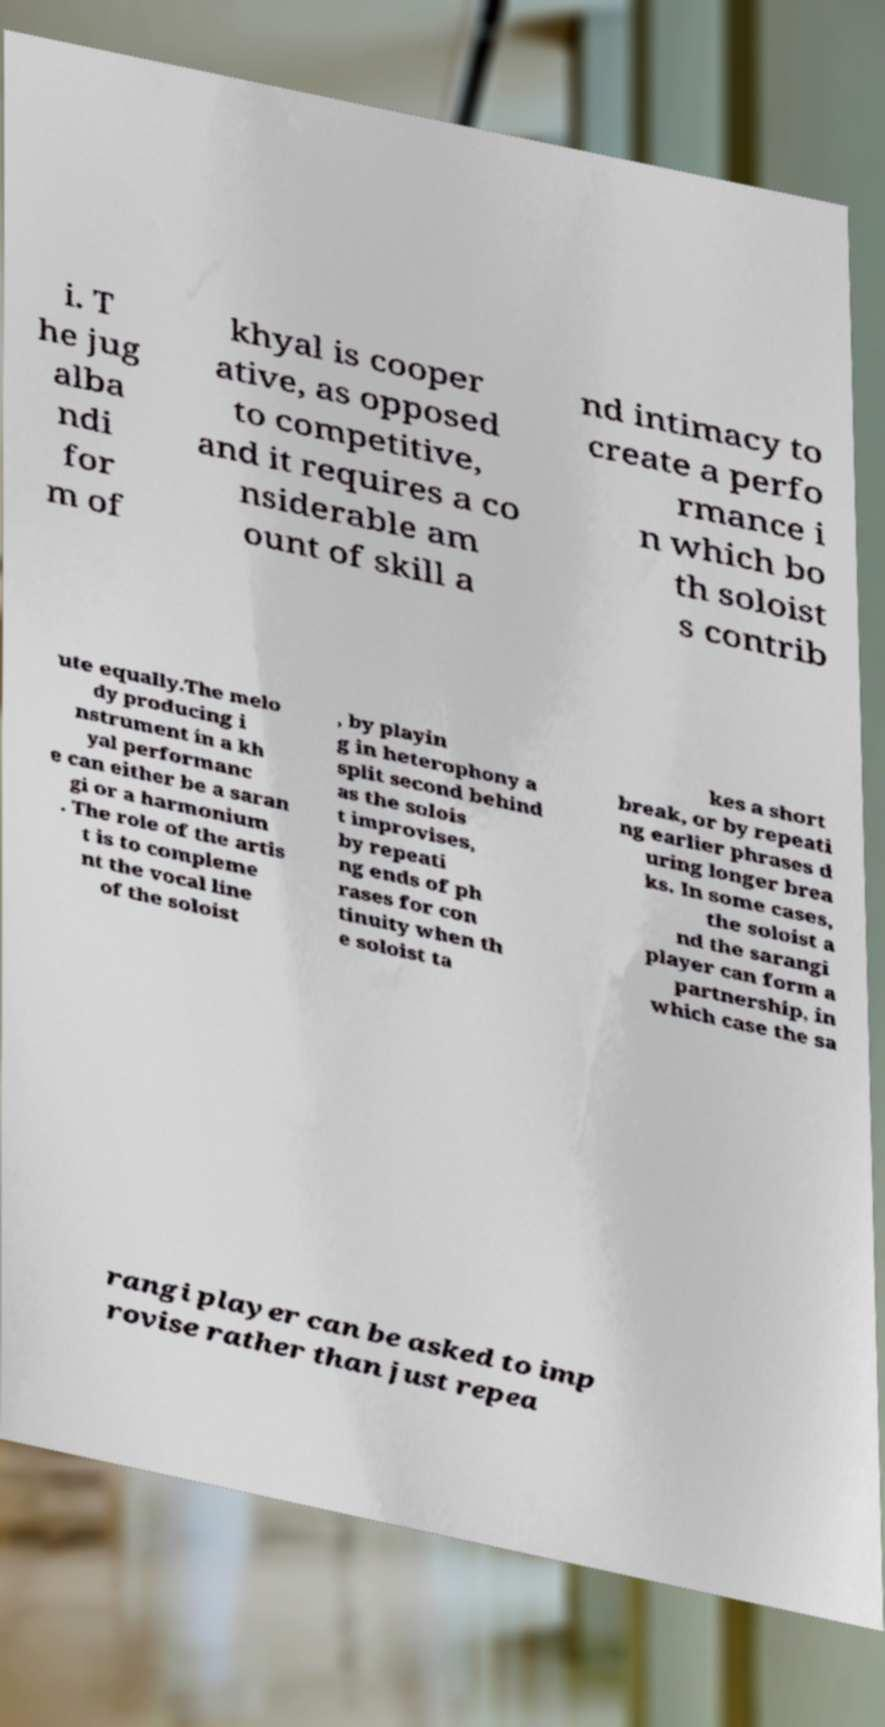There's text embedded in this image that I need extracted. Can you transcribe it verbatim? i. T he jug alba ndi for m of khyal is cooper ative, as opposed to competitive, and it requires a co nsiderable am ount of skill a nd intimacy to create a perfo rmance i n which bo th soloist s contrib ute equally.The melo dy producing i nstrument in a kh yal performanc e can either be a saran gi or a harmonium . The role of the artis t is to compleme nt the vocal line of the soloist , by playin g in heterophony a split second behind as the solois t improvises, by repeati ng ends of ph rases for con tinuity when th e soloist ta kes a short break, or by repeati ng earlier phrases d uring longer brea ks. In some cases, the soloist a nd the sarangi player can form a partnership, in which case the sa rangi player can be asked to imp rovise rather than just repea 